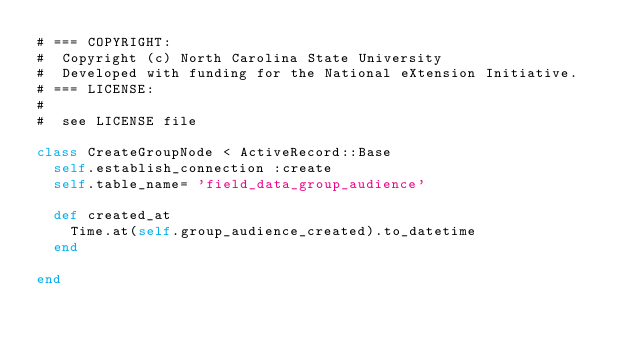<code> <loc_0><loc_0><loc_500><loc_500><_Ruby_># === COPYRIGHT:
#  Copyright (c) North Carolina State University
#  Developed with funding for the National eXtension Initiative.
# === LICENSE:
#
#  see LICENSE file

class CreateGroupNode < ActiveRecord::Base
  self.establish_connection :create
  self.table_name= 'field_data_group_audience'

  def created_at
    Time.at(self.group_audience_created).to_datetime
  end

end
</code> 